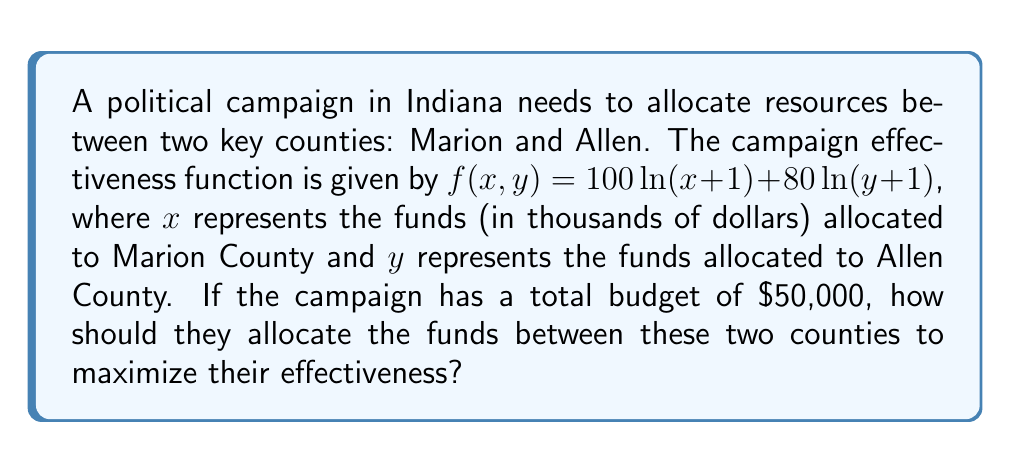Provide a solution to this math problem. To solve this optimization problem, we'll use the method of Lagrange multipliers:

1) Let's define our constraint function: $g(x, y) = x + y - 50 = 0$ (since $x$ and $y$ are in thousands)

2) Form the Lagrangian function:
   $L(x, y, \lambda) = f(x, y) - \lambda g(x, y)$
   $L(x, y, \lambda) = 100\ln(x+1) + 80\ln(y+1) - \lambda(x + y - 50)$

3) Calculate partial derivatives and set them equal to zero:

   $\frac{\partial L}{\partial x} = \frac{100}{x+1} - \lambda = 0$
   $\frac{\partial L}{\partial y} = \frac{80}{y+1} - \lambda = 0$
   $\frac{\partial L}{\partial \lambda} = x + y - 50 = 0$

4) From the first two equations:
   $\frac{100}{x+1} = \frac{80}{y+1} = \lambda$

5) This implies:
   $\frac{100}{x+1} = \frac{80}{y+1}$
   $100(y+1) = 80(x+1)$
   $100y + 100 = 80x + 80$
   $100y - 80x = -20$
   $5y - 4x = -1$ ... (Equation 1)

6) From the constraint:
   $x + y = 50$ ... (Equation 2)

7) Solve these two equations:
   Multiply Equation 1 by 4 and Equation 2 by 5:
   $20y - 16x = -4$
   $5x + 5y = 250$

   Add these equations:
   $25y - 11x = 246$

   Substitute $y = 50 - x$ from Equation 2:
   $25(50-x) - 11x = 246$
   $1250 - 36x = 246$
   $1004 = 36x$
   $x = 27.89$

8) Substitute this value of $x$ back into Equation 2:
   $y = 50 - 27.89 = 22.11$

Therefore, the optimal allocation is approximately $27,890 to Marion County and $22,110 to Allen County.
Answer: $27,890 to Marion County, $22,110 to Allen County 